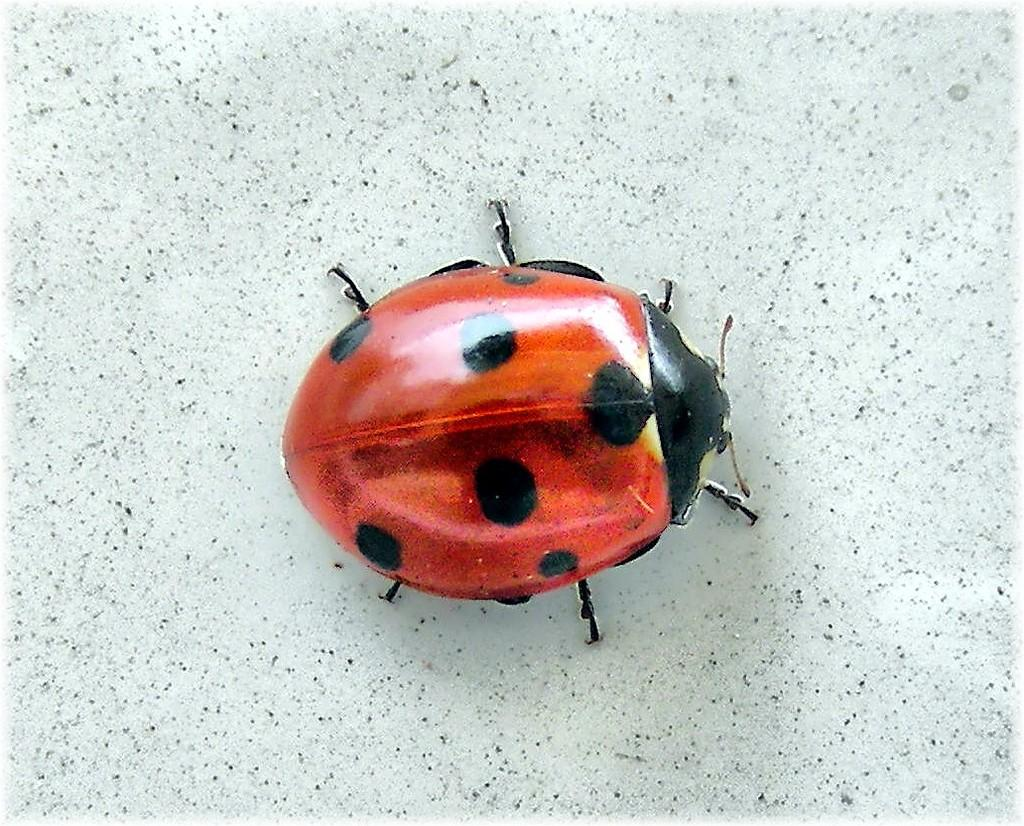What type of creature is present in the image? There is an insect in the image. What colors can be seen on the insect? The insect has red and black colors. What can be seen in the background of the image? There is a floor visible in the background of the image. What type of belief is being discussed in the image? There is no discussion of beliefs in the image; it features an insect with red and black colors against a background of a floor. 